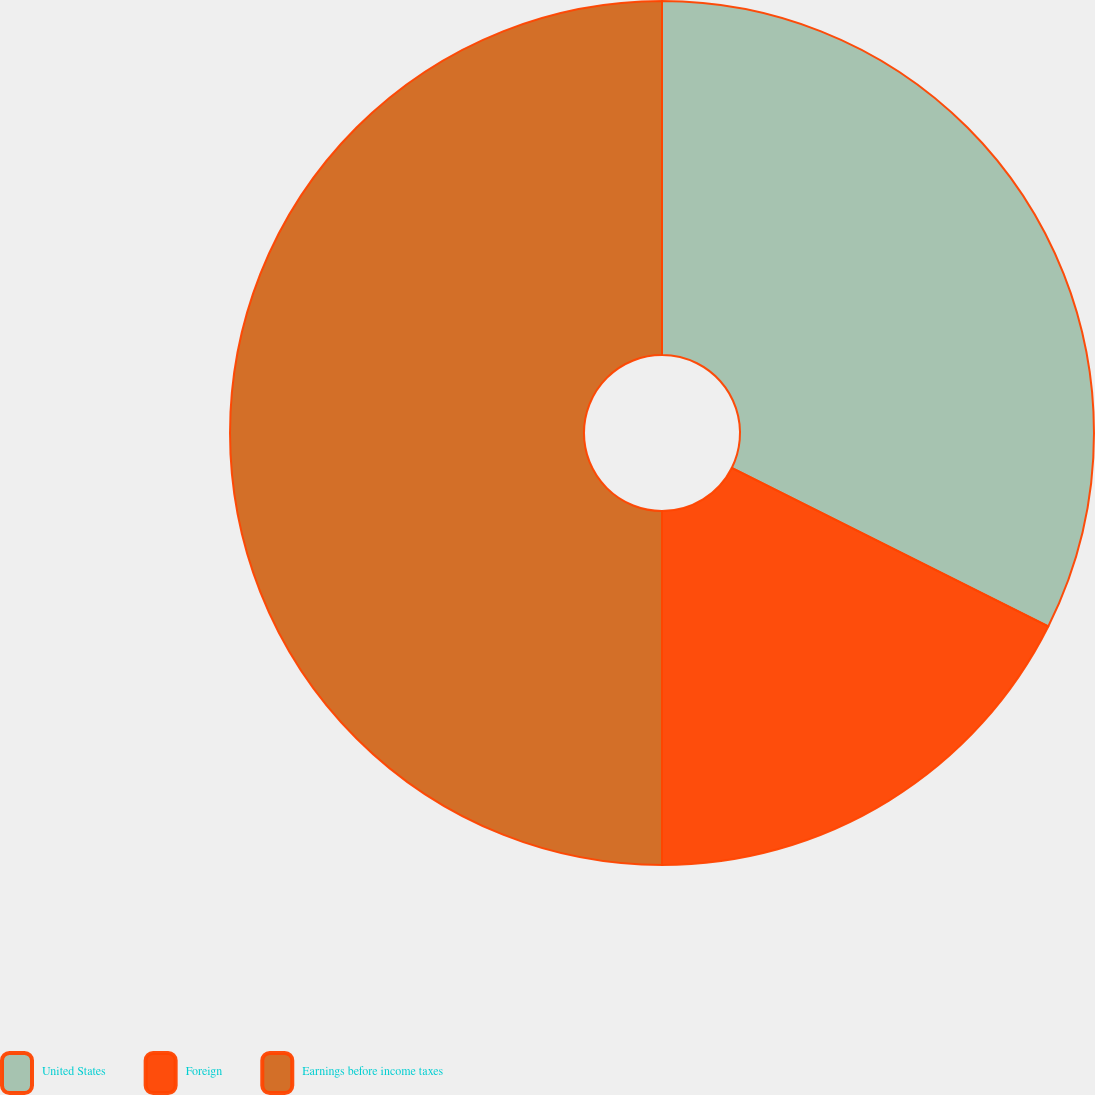Convert chart. <chart><loc_0><loc_0><loc_500><loc_500><pie_chart><fcel>United States<fcel>Foreign<fcel>Earnings before income taxes<nl><fcel>32.39%<fcel>17.61%<fcel>50.0%<nl></chart> 